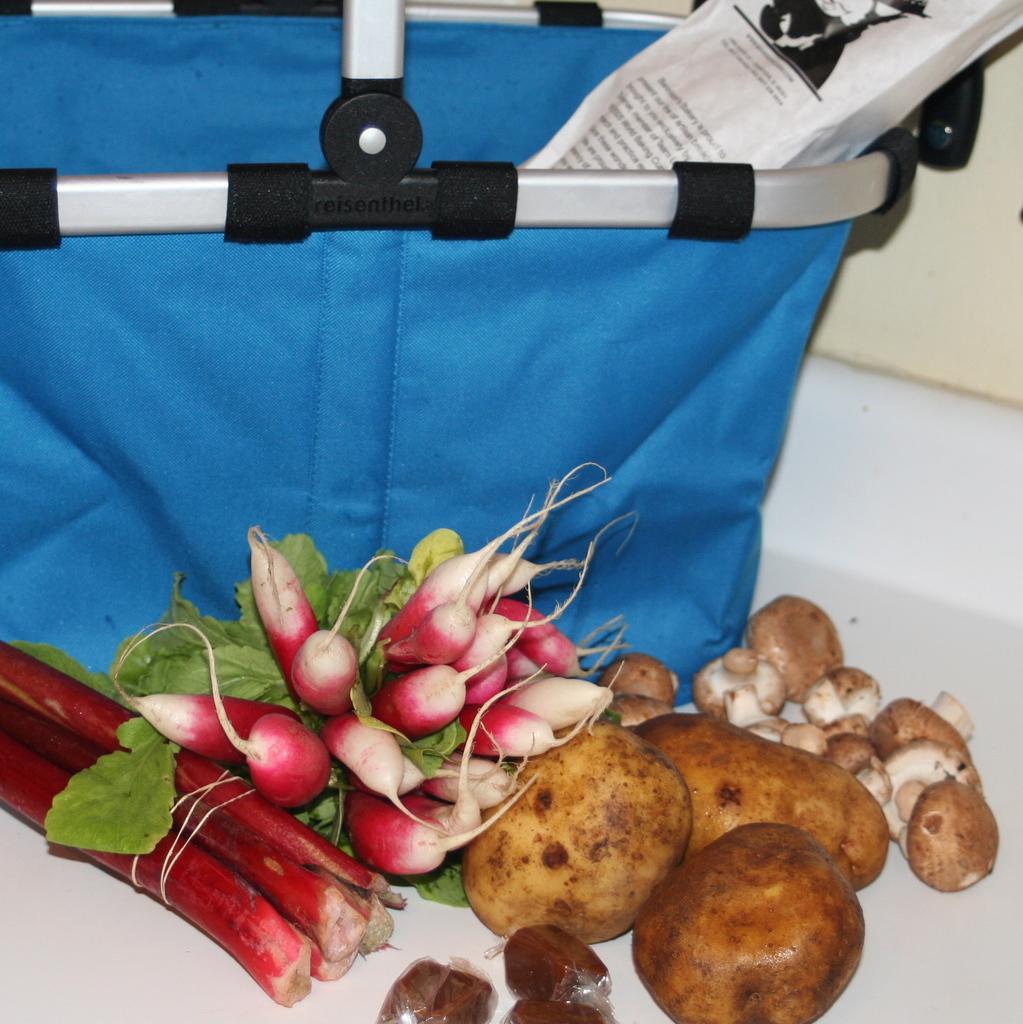How would you summarize this image in a sentence or two? In this picture, there are vegetables like potatoes, radish, mushroom are placed on the ground. On the top, there is a blue bag. 